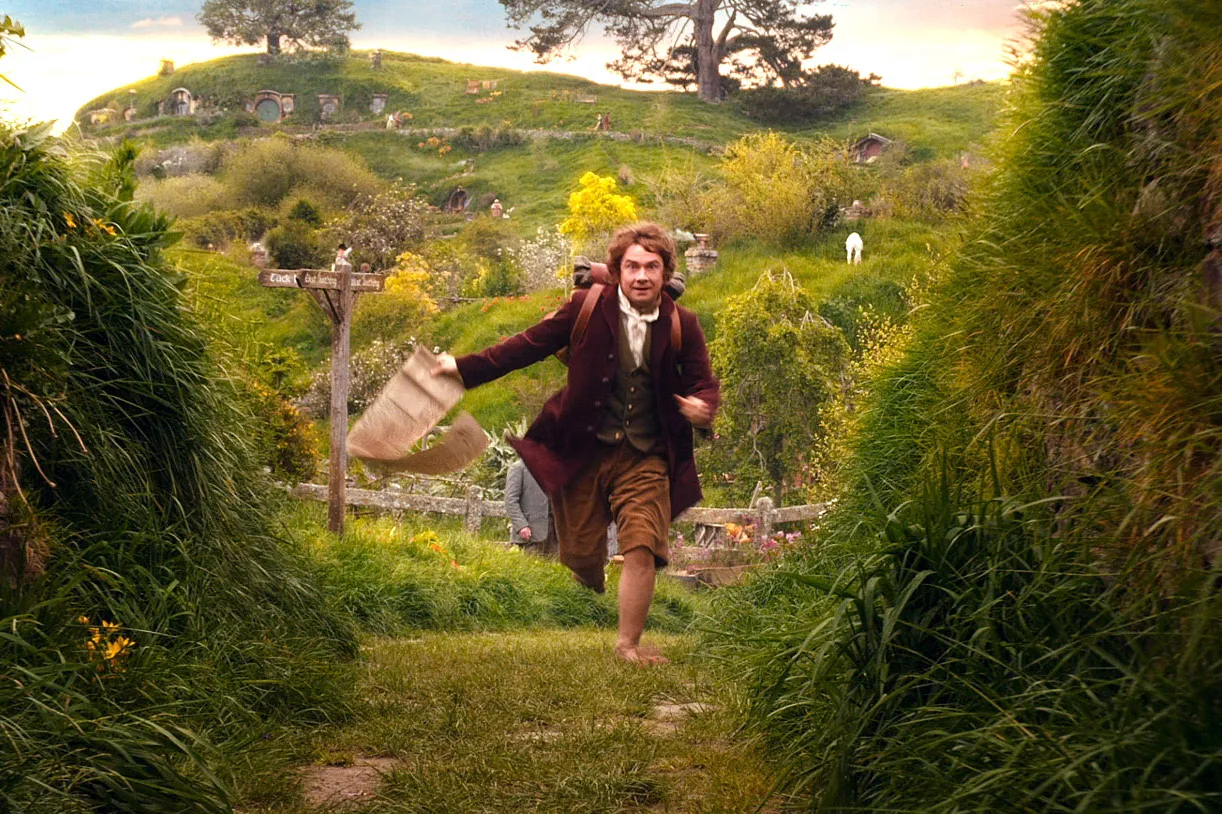Can you describe the architectural style of the homes in the background? The homes in the background feature a distinctive architectural style with circular doors and grass-covered roofs, nestled into lush hillside landscapes. This style is quintessentially associated with hobbit homes, as seen in various fantasy literature and films, designed to blend seamlessly into the natural environment and reflect a peaceful, earthy community lifestyle. 